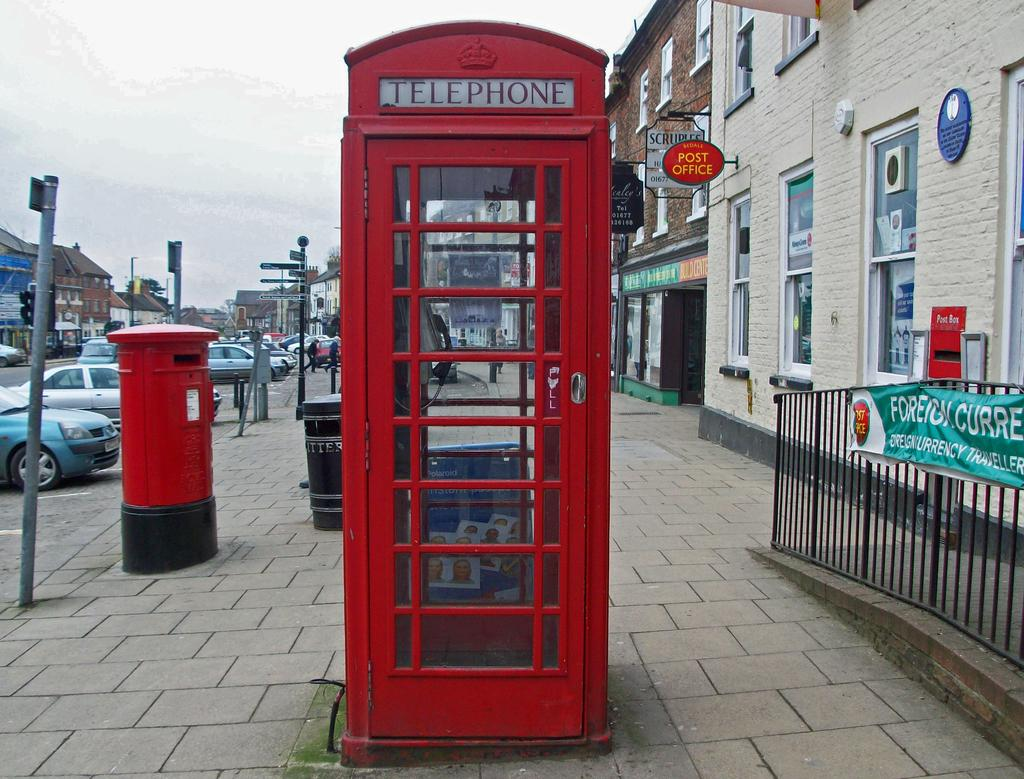<image>
Describe the image concisely. A red British telephone box is located next to a matching mail box. 